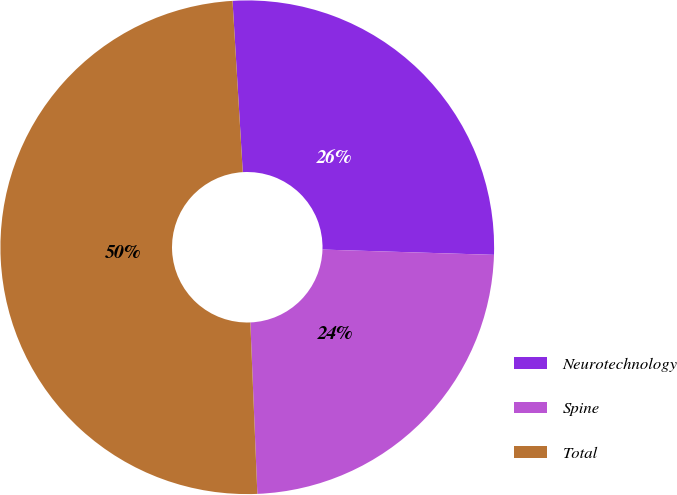Convert chart. <chart><loc_0><loc_0><loc_500><loc_500><pie_chart><fcel>Neurotechnology<fcel>Spine<fcel>Total<nl><fcel>26.44%<fcel>23.86%<fcel>49.7%<nl></chart> 